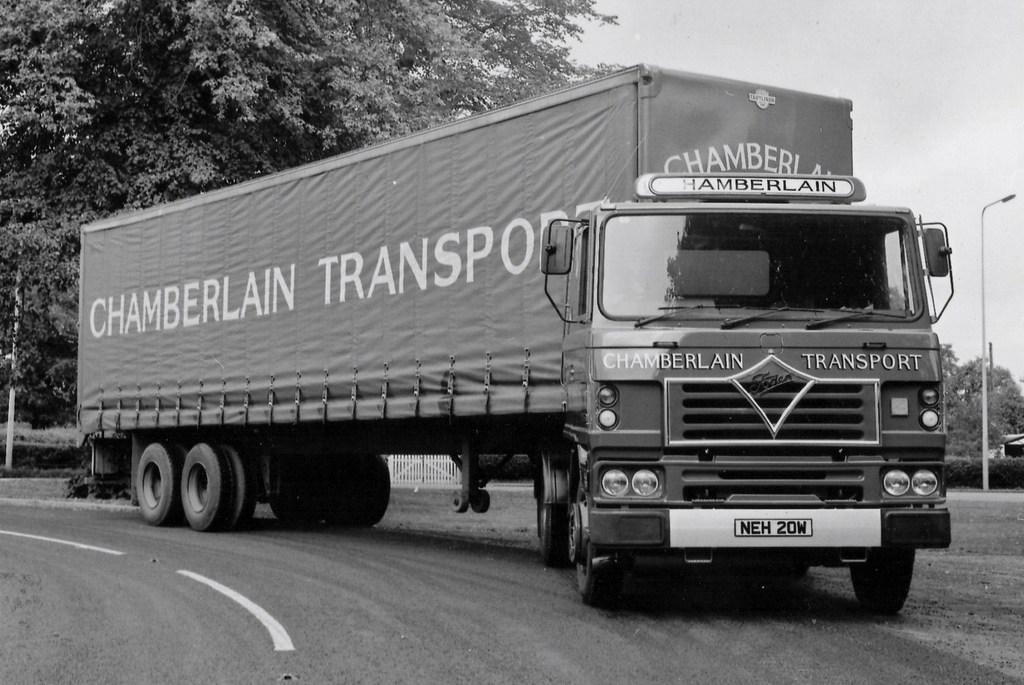What is the main subject of the image? There is a vehicle on the road in the image. What can be seen beside the road in the image? There are trees and poles beside the road in the image. What type of holiday is being celebrated in the image? There is no indication of a holiday being celebrated in the image, as it primarily features a vehicle on the road and trees and poles beside the road. 